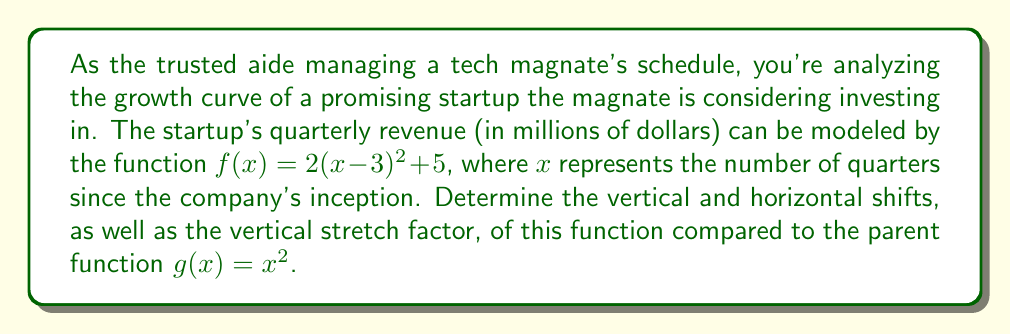Provide a solution to this math problem. To determine the shifts and scale of the given quadratic function, we need to compare it to the parent function $g(x) = x^2$. Let's break down the process step-by-step:

1. Given function: $f(x) = 2(x-3)^2 + 5$

2. Identify the general form of a transformed quadratic function:
   $f(x) = a(x-h)^2 + k$
   Where:
   - $a$ is the vertical stretch factor
   - $h$ is the horizontal shift
   - $k$ is the vertical shift

3. Compare our function to the general form:
   $f(x) = 2(x-3)^2 + 5$
   
   We can see that:
   - $a = 2$
   - $h = 3$
   - $k = 5$

4. Interpret the results:
   - Vertical stretch: The factor $a = 2$ indicates that the parabola is stretched vertically by a factor of 2 compared to the parent function.
   - Horizontal shift: The term $(x-3)$ indicates a horizontal shift of 3 units to the right.
   - Vertical shift: The $+5$ at the end indicates a vertical shift of 5 units upward.

5. Verify the shifts:
   - The vertex of the parabola is at $(3, 5)$, which confirms both the horizontal and vertical shifts.
Answer: Compared to the parent function $g(x) = x^2$:
- Vertical stretch factor: 2
- Horizontal shift: 3 units right
- Vertical shift: 5 units up 